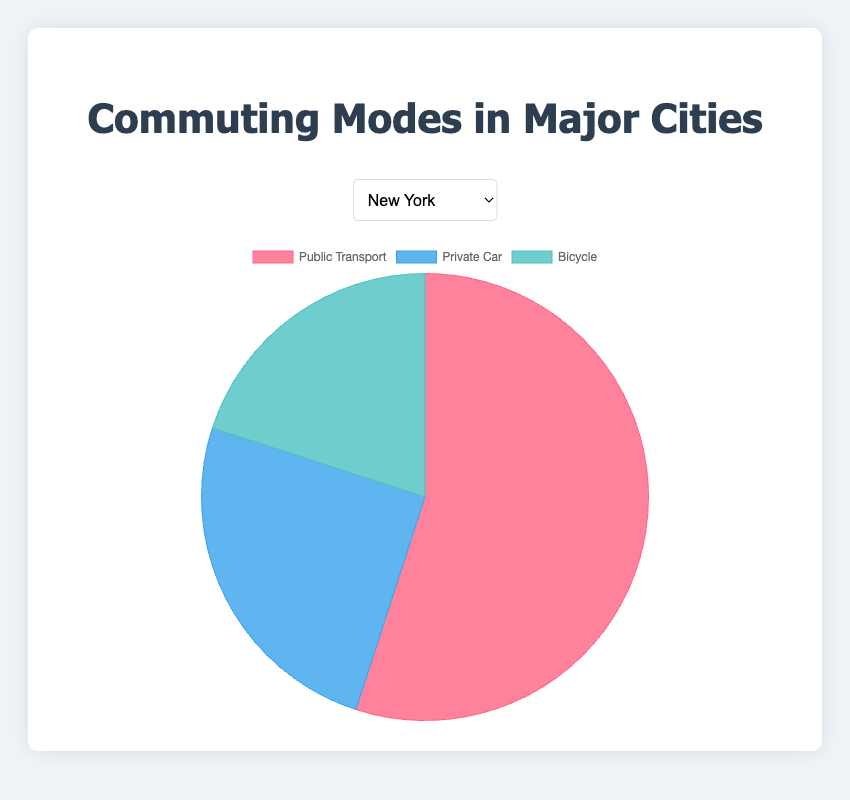What's the dominant mode of commuting in Amsterdam? The largest segment in the pie represents bicycles, occupying 45% in Amsterdam.
Answer: Bicycles Compare the use of public transport between New York and Berlin. Which city uses it more? New York has a public transport segment of 55%, whereas Berlin has 50%. Therefore, public transport use is higher in New York.
Answer: New York Which city has the smallest proportion of people using bicycles? Tokyo has the smallest bicycle segment at 15%.
Answer: Tokyo In San Francisco, what is the combined percentage of commuting by private car and bicycle? The private car and bicycle segments in San Francisco are both 30%. So, combined it's 30% + 30% = 60%.
Answer: 60% How does the proportion of private car usage in Berlin compare to that in Amsterdam? Both Berlin and Amsterdam have the same proportion of private car usage, which is 20%.
Answer: Equal Which mode of commuting has the second-highest percentage in Tokyo? For Tokyo, the second-largest segment is private car usage at 25%.
Answer: Private Car What is the total percentage of people using public transport across New York, Berlin, and Amsterdam? The percentages for public transport are: New York 55%, Berlin 50%, and Amsterdam 35%. Sum: 55% + 50% + 35% = 140%.
Answer: 140% Calculate the average percentage of people using bicycles in all five cities. The bicycle percentages are: 20% (New York), 30% (San Francisco), 45% (Amsterdam), 15% (Tokyo), and 20% (Berlin). Sum: 20% + 30% + 45% + 15% + 20% = 130%. Average: 130% / 5 = 26%.
Answer: 26% What color represents public transport across all cities in the plot? The color used to represent public transport in the chart is red.
Answer: Red 